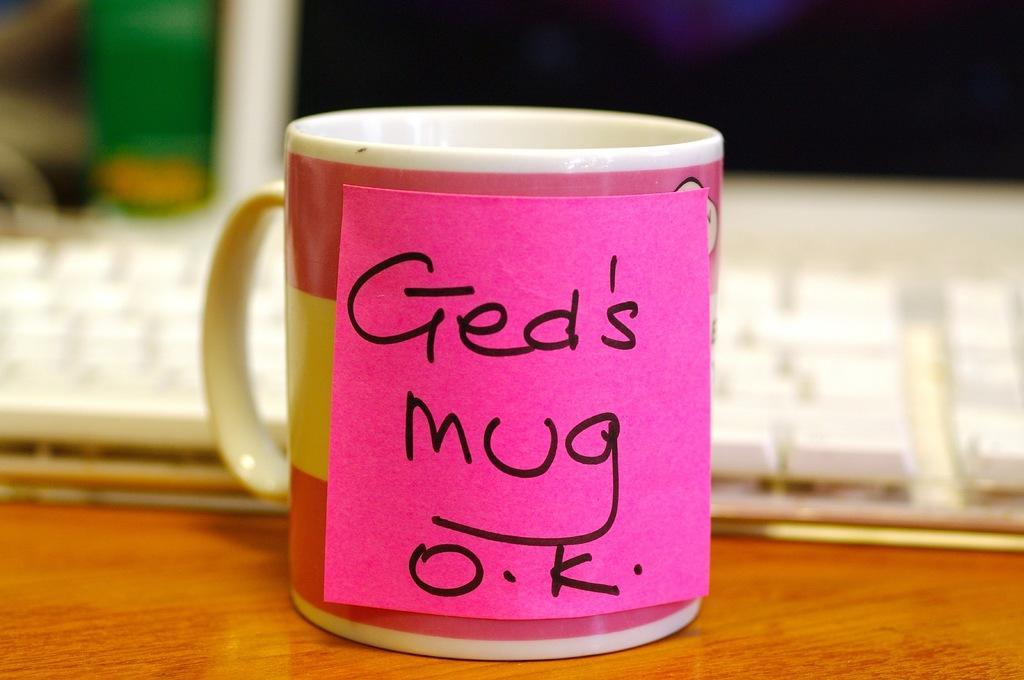<image>
Offer a succinct explanation of the picture presented. A mug with a post it on it saying "Ged's mug o.k." 